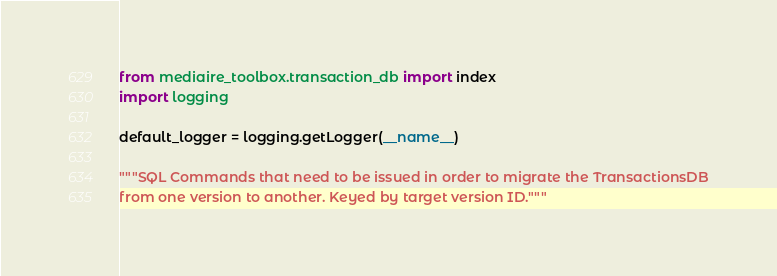<code> <loc_0><loc_0><loc_500><loc_500><_Python_>from mediaire_toolbox.transaction_db import index
import logging

default_logger = logging.getLogger(__name__)

"""SQL Commands that need to be issued in order to migrate the TransactionsDB
from one version to another. Keyed by target version ID."""</code> 